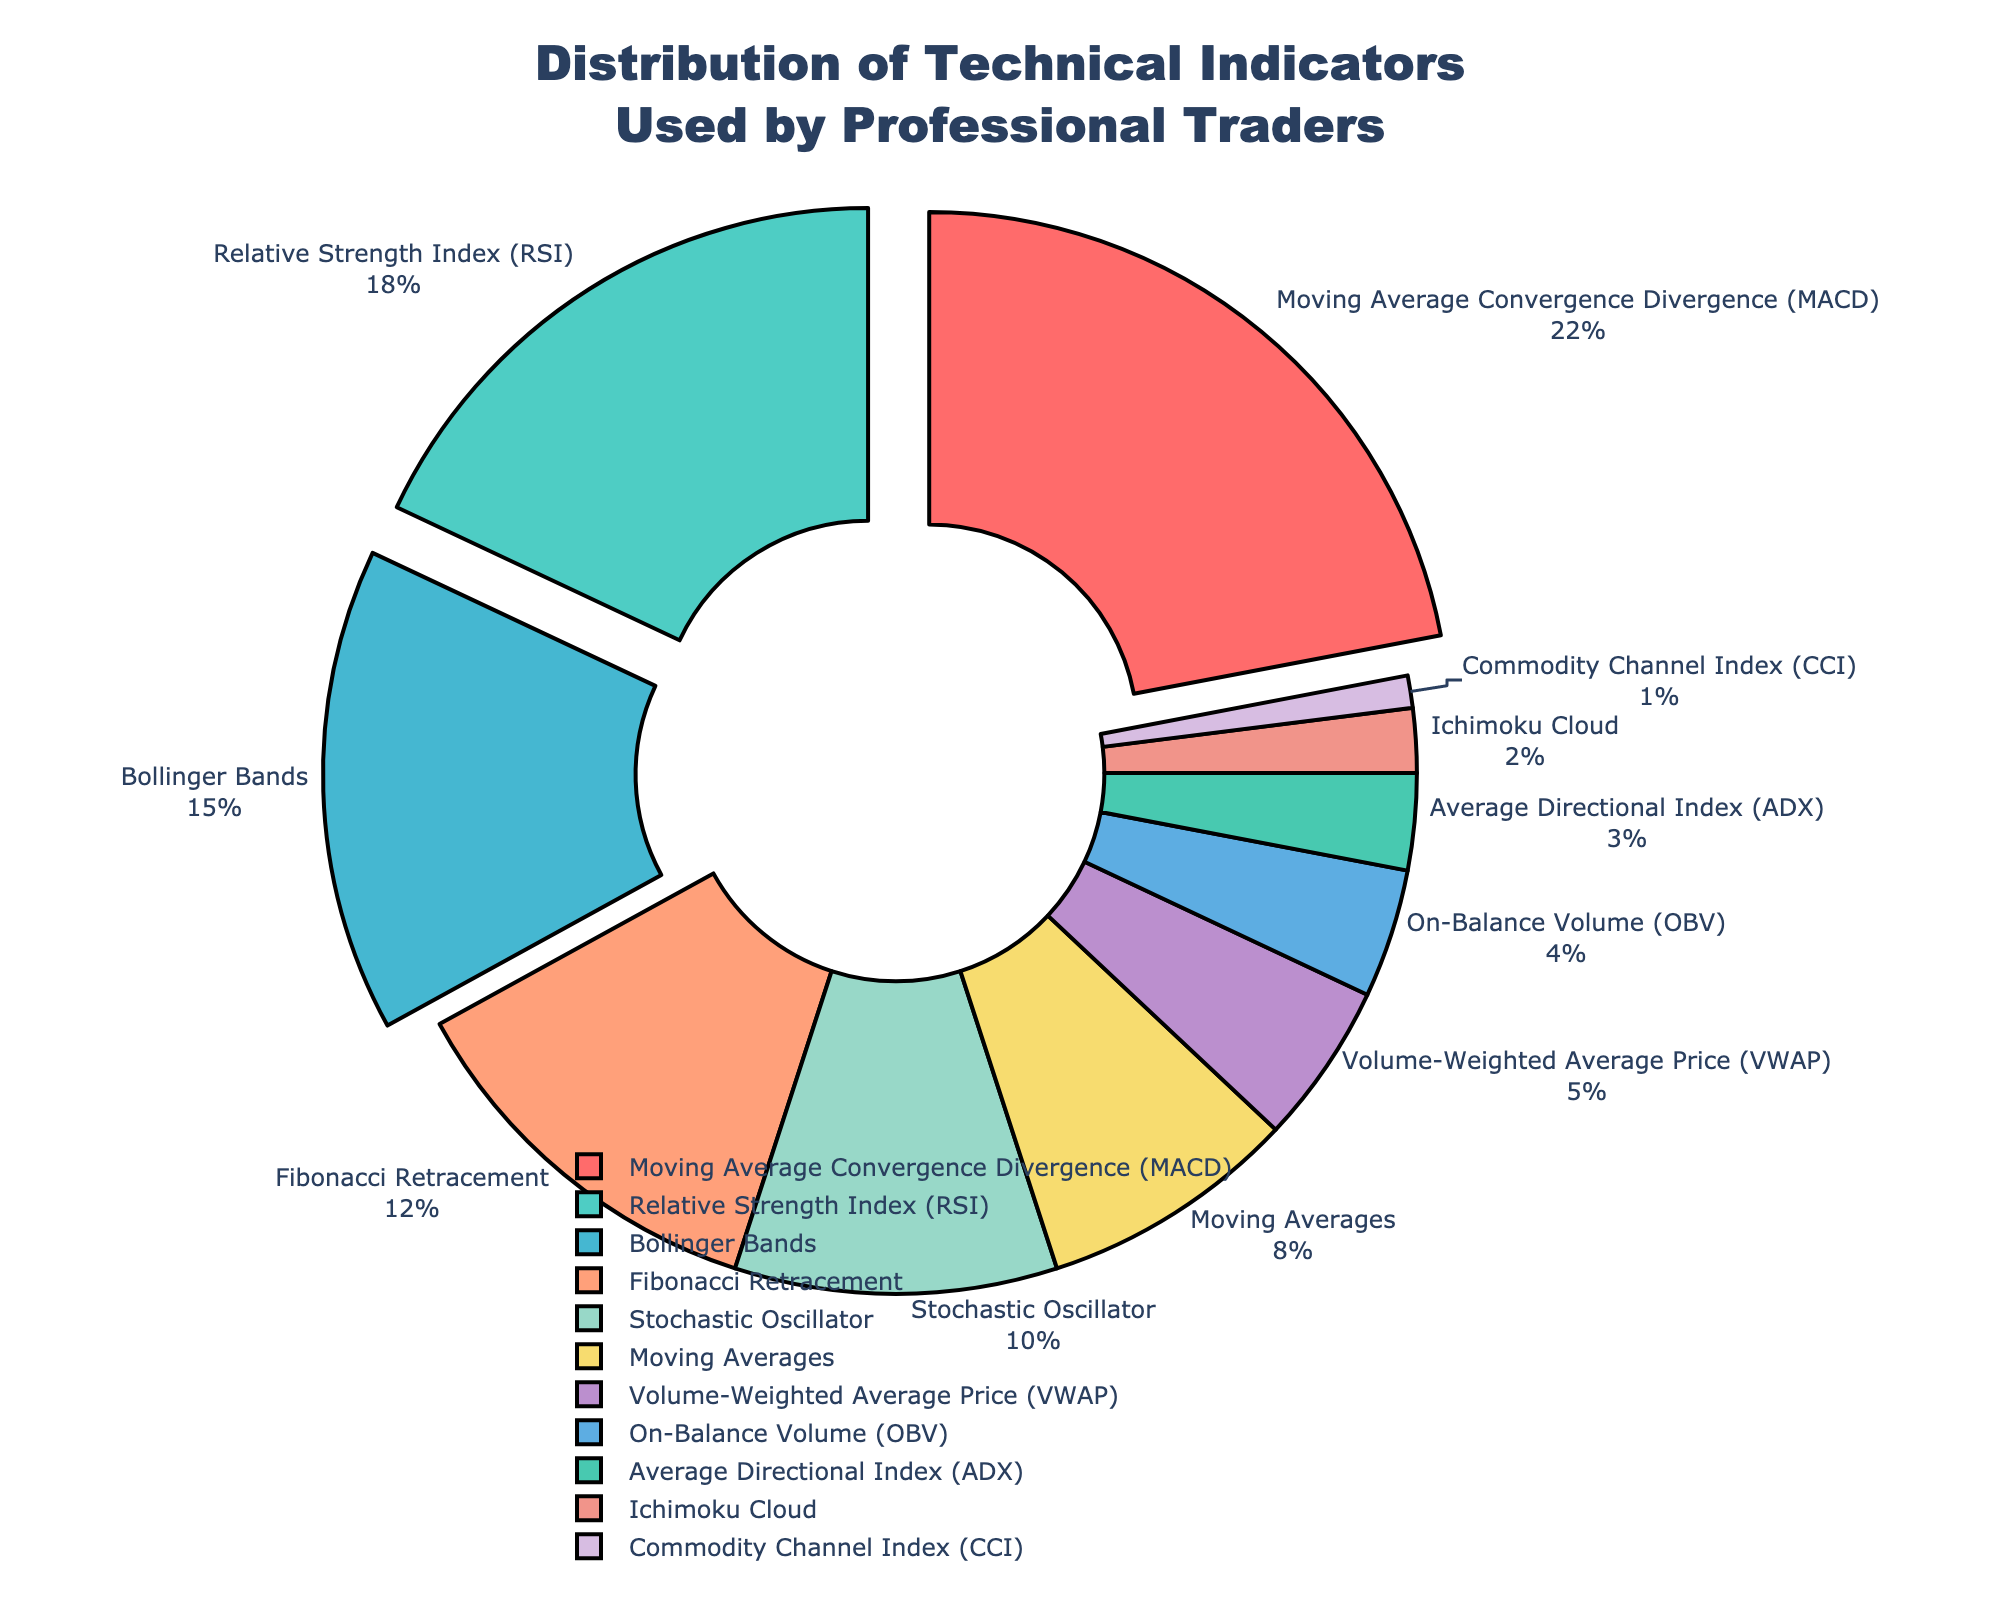What percentage of traders use Moving Average Convergence Divergence (MACD)? From the pie chart, look for the segment labeled "Moving Average Convergence Divergence (MACD)" and read the percentage indicated next to it.
Answer: 22% Which indicator is used less frequently, On-Balance Volume (OBV) or Volume-Weighted Average Price (VWAP)? Compare the percentages for "On-Balance Volume (OBV)" and "Volume-Weighted Average Price (VWAP)" from the pie chart. OBV has 4%, while VWAP has 5%.
Answer: OBV What's the combined percentage of traders using Bollinger Bands and Relative Strength Index (RSI)? Find the percentages for Bollinger Bands (15%) and RSI (18%) from the chart, and add them together: 15% + 18% = 33%.
Answer: 33% Which indicator is represented by the smallest segment, and what is its percentage? Look for the smallest segment on the pie chart. It is labeled "Commodity Channel Index (CCI)", and it has a percentage of 1%.
Answer: Commodity Channel Index (CCI) with 1% How much more frequently is the MACD used compared to the Ichimoku Cloud? Get the percentages for MACD (22%) and Ichimoku Cloud (2%) from the chart, and then subtract the smaller from the larger: 22% - 2% = 20%.
Answer: 20% Which color represents the Relative Strength Index (RSI)? Identify the segment labeled "Relative Strength Index (RSI)" on the pie chart and note its color, which is green.
Answer: Green Are there more traders using Fibonacci Retracement or Stochastic Oscillator? By how much? Compare the percentages for Fibonacci Retracement (12%) and Stochastic Oscillator (10%). Fibonacci Retracement is used more frequently by 12% - 10% = 2%.
Answer: Fibonacci Retracement by 2% What is the percentage difference between the use of Moving Averages and the Commodity Channel Index (CCI)? Find the percentages for Moving Averages (8%) and Commodity Channel Index (CCI) (1%) from the pie chart, and calculate the difference: 8% - 1% = 7%.
Answer: 7% What is the cumulative percentage of all indicators collectively used by less than 5% of traders each? Identify the indicators with percentages less than 5% from the chart: VWAP (5% not included), OBV (4%), ADX (3%), Ichimoku Cloud (2%), and CCI (1%), and sum them: 4% + 3% + 2% + 1% = 10%.
Answer: 10% Which three indicators are pulled out from the pie chart? Observe the three segments that are visually pulled out from the pie chart. They are labeled MACD, RSI, and Bollinger Bands.
Answer: MACD, RSI, Bollinger Bands 